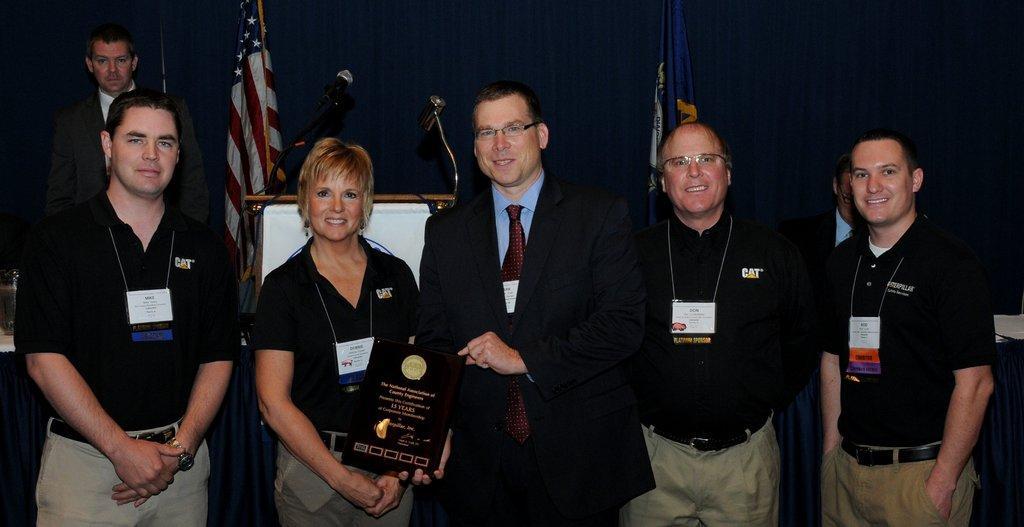In one or two sentences, can you explain what this image depicts? In this image we can see people standing. The man standing in the center is holding a memorandum. In the background there is a podium and there are mics placed on the podium. We can see flags and a curtain. 